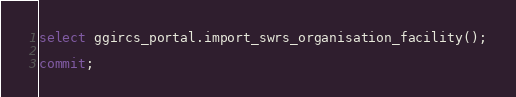Convert code to text. <code><loc_0><loc_0><loc_500><loc_500><_SQL_>
select ggircs_portal.import_swrs_organisation_facility();

commit;
</code> 